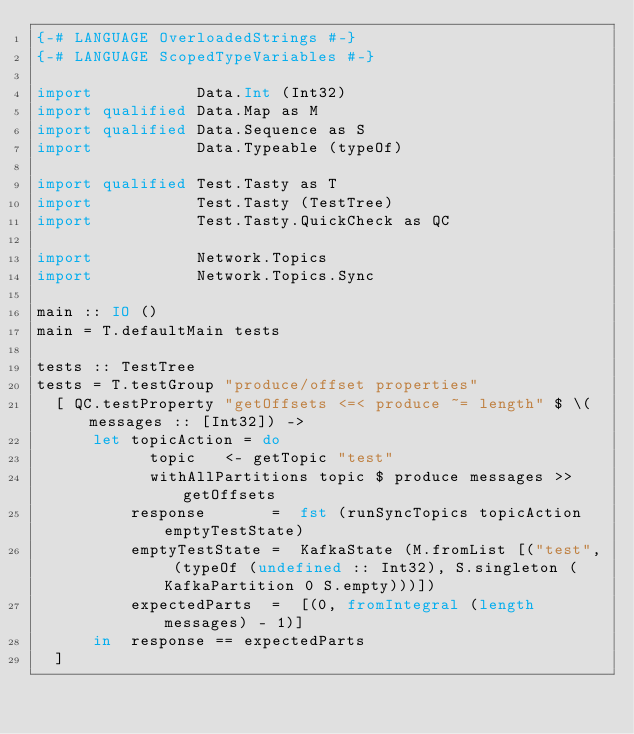<code> <loc_0><loc_0><loc_500><loc_500><_Haskell_>{-# LANGUAGE OverloadedStrings #-}
{-# LANGUAGE ScopedTypeVariables #-}

import           Data.Int (Int32)
import qualified Data.Map as M
import qualified Data.Sequence as S
import           Data.Typeable (typeOf)

import qualified Test.Tasty as T
import           Test.Tasty (TestTree)
import           Test.Tasty.QuickCheck as QC

import           Network.Topics
import           Network.Topics.Sync

main :: IO ()
main = T.defaultMain tests

tests :: TestTree
tests = T.testGroup "produce/offset properties"
  [ QC.testProperty "getOffsets <=< produce ~= length" $ \(messages :: [Int32]) ->
      let topicAction = do
            topic   <- getTopic "test"
            withAllPartitions topic $ produce messages >> getOffsets
          response       =  fst (runSyncTopics topicAction emptyTestState)
          emptyTestState =  KafkaState (M.fromList [("test", (typeOf (undefined :: Int32), S.singleton (KafkaPartition 0 S.empty)))])
          expectedParts  =  [(0, fromIntegral (length messages) - 1)]
      in  response == expectedParts
  ]
</code> 